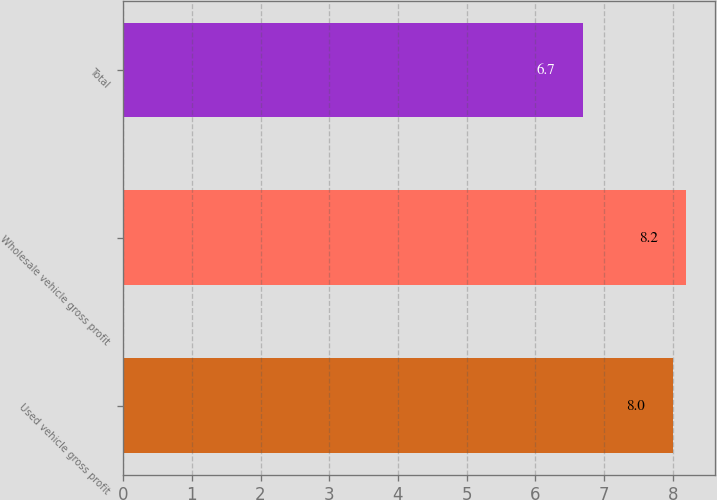Convert chart to OTSL. <chart><loc_0><loc_0><loc_500><loc_500><bar_chart><fcel>Used vehicle gross profit<fcel>Wholesale vehicle gross profit<fcel>Total<nl><fcel>8<fcel>8.2<fcel>6.7<nl></chart> 